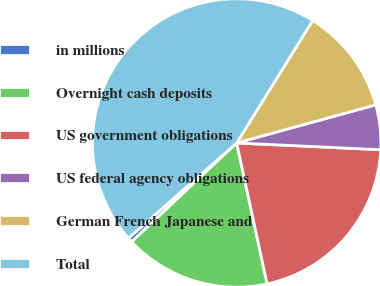<chart> <loc_0><loc_0><loc_500><loc_500><pie_chart><fcel>in millions<fcel>Overnight cash deposits<fcel>US government obligations<fcel>US federal agency obligations<fcel>German French Japanese and<fcel>Total<nl><fcel>0.53%<fcel>16.38%<fcel>20.86%<fcel>5.01%<fcel>11.9%<fcel>45.33%<nl></chart> 